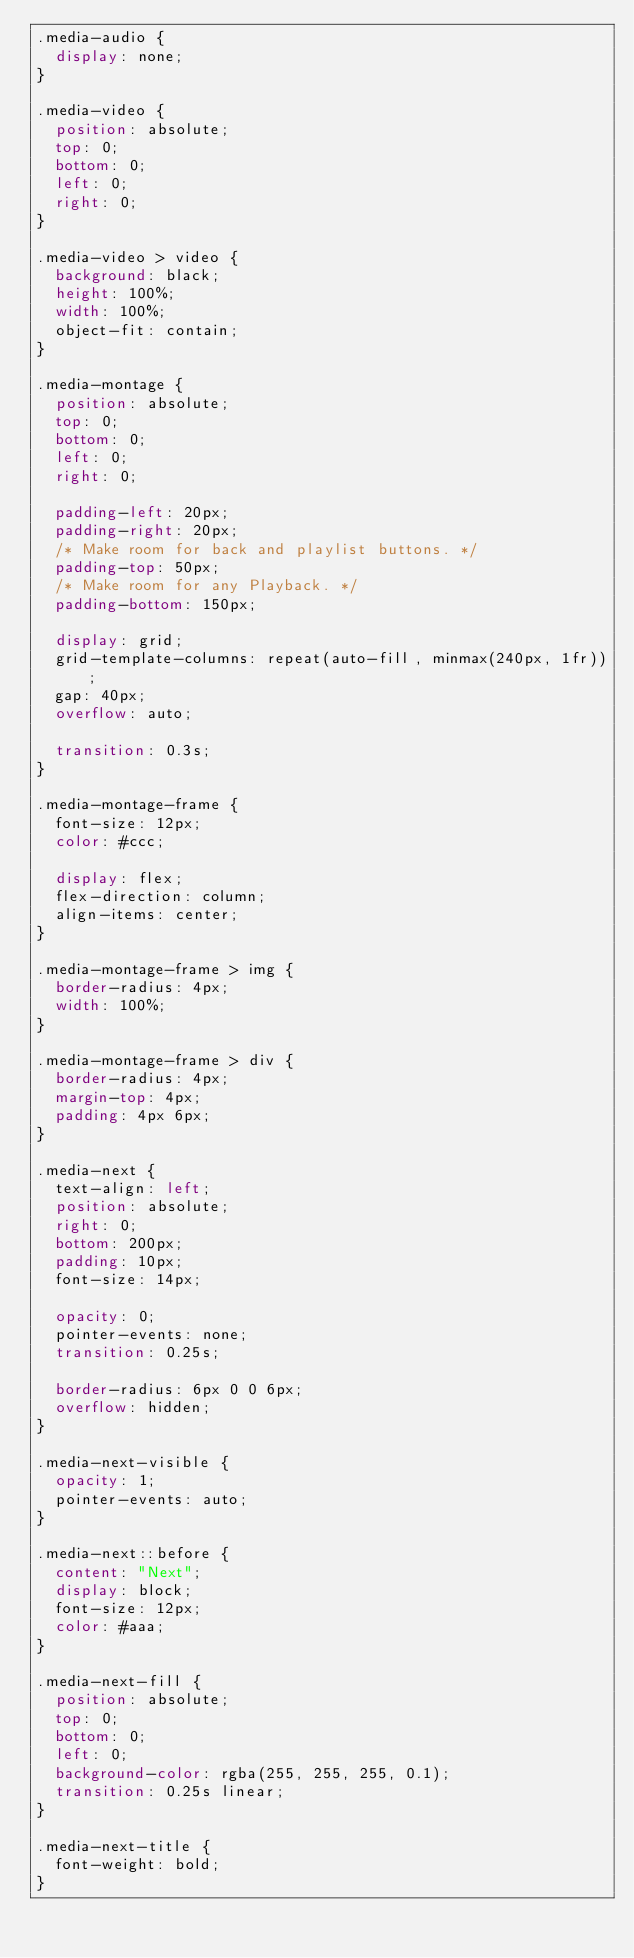<code> <loc_0><loc_0><loc_500><loc_500><_CSS_>.media-audio {
  display: none;
}

.media-video {
  position: absolute;
  top: 0;
  bottom: 0;
  left: 0;
  right: 0;
}

.media-video > video {
  background: black;
  height: 100%;
  width: 100%;
  object-fit: contain;
}

.media-montage {
  position: absolute;
  top: 0;
  bottom: 0;
  left: 0;
  right: 0;

  padding-left: 20px;
  padding-right: 20px;
  /* Make room for back and playlist buttons. */
  padding-top: 50px;
  /* Make room for any Playback. */
  padding-bottom: 150px;

  display: grid;
  grid-template-columns: repeat(auto-fill, minmax(240px, 1fr));
  gap: 40px;
  overflow: auto;

  transition: 0.3s;
}

.media-montage-frame {
  font-size: 12px;
  color: #ccc;

  display: flex;
  flex-direction: column;
  align-items: center;
}

.media-montage-frame > img {
  border-radius: 4px;
  width: 100%;
}

.media-montage-frame > div {
  border-radius: 4px;
  margin-top: 4px;
  padding: 4px 6px;
}

.media-next {
  text-align: left;
  position: absolute;
  right: 0;
  bottom: 200px;
  padding: 10px;
  font-size: 14px;

  opacity: 0;
  pointer-events: none;
  transition: 0.25s;

  border-radius: 6px 0 0 6px;
  overflow: hidden;
}

.media-next-visible {
  opacity: 1;
  pointer-events: auto;
}

.media-next::before {
  content: "Next";
  display: block;
  font-size: 12px;
  color: #aaa;
}

.media-next-fill {
  position: absolute;
  top: 0;
  bottom: 0;
  left: 0;
  background-color: rgba(255, 255, 255, 0.1);
  transition: 0.25s linear;
}

.media-next-title {
  font-weight: bold;
}
</code> 